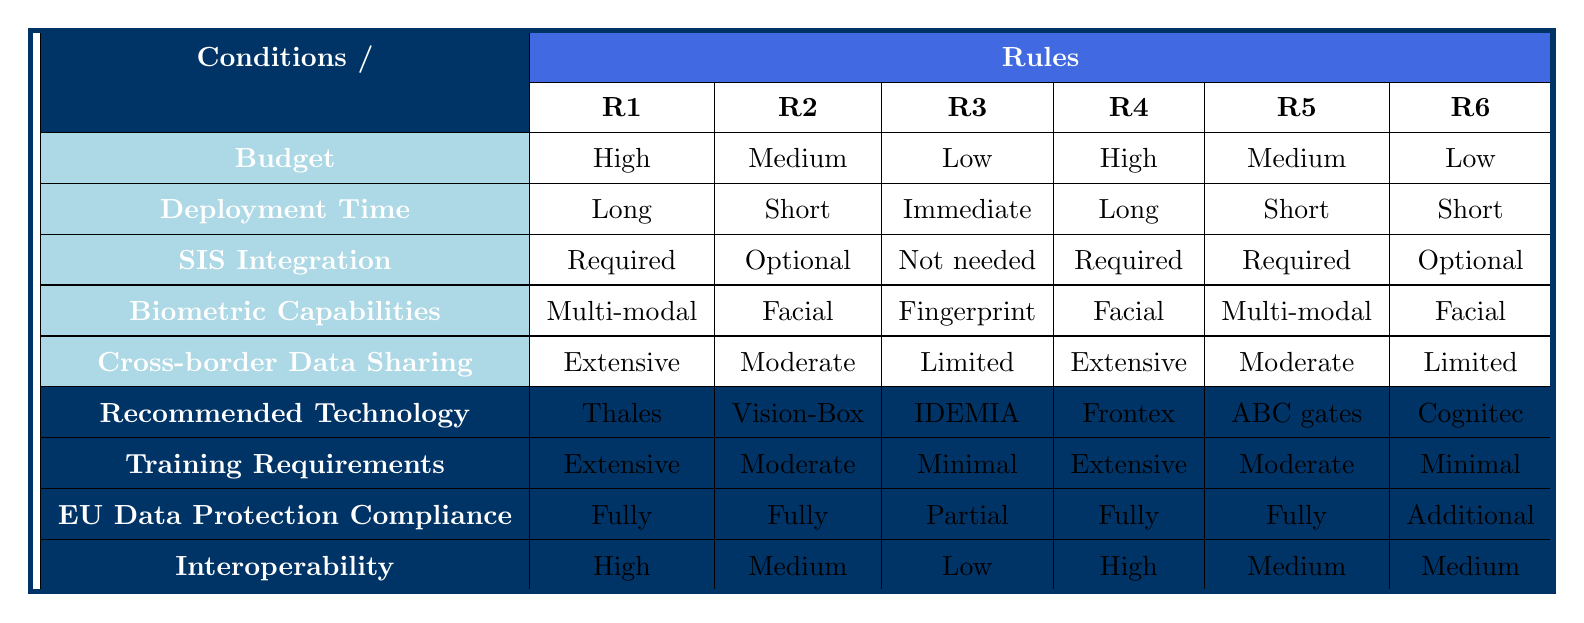What technology is recommended for a medium budget with short-term deployment, optional SIS integration, facial recognition capabilities, and moderate data sharing? To answer this, we will look for the rule that matches the conditions: Medium budget, Short-term deployment (1-6 months), Optional SIS integration, Facial recognition, and Moderate data sharing. Referring to the table, this matches R2. Thus, the recommended technology is Vision-Box Orchestra platform.
Answer: Vision-Box Orchestra platform Is extensive training required for the Thales Gemalto Border Management System? Looking at the row for the recommended technology Thales Gemalto Border Management System, we can see that the training requirements listed are extensive.
Answer: Yes What is the interoperability level of the IDEMIA MorphoWave Compact? Referring to the row for the IDEMIA MorphoWave Compact in the table, the interoperability is marked as low.
Answer: Low Are there any technologies recommended for a low budget and immediate deployment time? We can check the rows for any technology that matches the conditions of a low budget and immediate deployment time. In R3, the recommended technology is IDEMIA MorphoWave Compact, which satisfies these conditions.
Answer: Yes What is the average training requirement level for all technologies listed in the table? To calculate the average, we identify the training requirements: Extensive (2), Moderate (3), Minimal (2). If we assign values: Extensive = 3, Moderate = 2, Minimal = 1, the average becomes (3*2 + 2*3 + 1*2)/7 = 2. This translates to a moderate training requirement level.
Answer: Moderate 